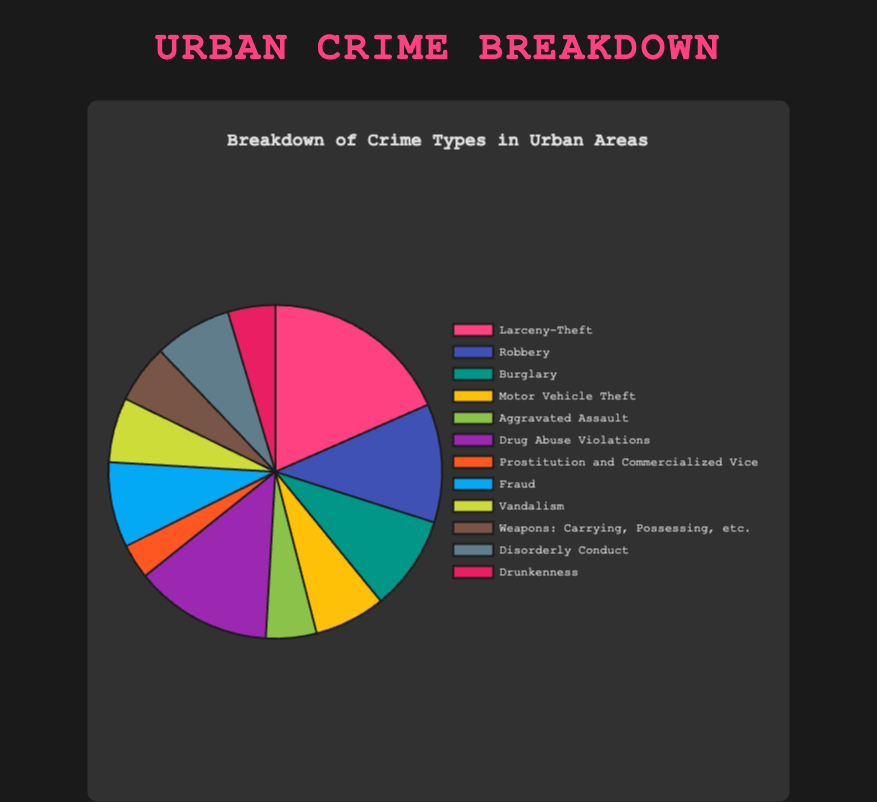What is the most frequent crime type represented in the pie chart? The pie chart shows different crime types with counts. Larceny-Theft has the largest slice, which indicates it is the most frequent crime type with 1200 counts.
Answer: Larceny-Theft Which crime type has a count closest to the average crime count? First, sum all the counts: 1200 + 750 + 600 + 450 + 320 + 870 + 220 + 540 + 410 + 370 + 490 + 300 = 6520. Then, divide by the number of crime types (12). 6520 / 12 = 543.33. Fraud, with a count of 540, is closest to this average.
Answer: Fraud What is the total count for non-violent crimes in the chart? Non-violent crimes here include Larceny-Theft, Burglary, Motor Vehicle Theft, Drug Abuse Violations, Prostitution and Commercialized Vice, Fraud, and Vandalism. Add these counts: 1200 + 600 + 450 + 870 + 220 + 540 + 410 = 4290.
Answer: 4290 Which crime has a larger count: Drug Abuse Violations or Robbery? Compare the two counts: Drug Abuse Violations (870) versus Robbery (750). Drug Abuse Violations has a larger count.
Answer: Drug Abuse Violations What is the combined count of crimes related to theft (Larceny-Theft, Burglary, Motor Vehicle Theft)? Add the counts of the three theft-related crimes: 1200 (Larceny-Theft) + 600 (Burglary) + 450 (Motor Vehicle Theft) = 2250.
Answer: 2250 How many more instances of Larceny-Theft are there compared to Burglary? Subtract the count of Burglary from Larceny-Theft: 1200 - 600 = 600.
Answer: 600 Which crime type is represented by a blue color slice in the pie chart? Referring to the visual attributes, Robbery is represented by the blue color slice.
Answer: Robbery How does the count for Disorderly Conduct compare to that for Vandalism? Compare the two counts: Disorderly Conduct (490) versus Vandalism (410). Disorderly Conduct has more counts.
Answer: Disorderly Conduct What proportion of the total does Aggravated Assault represent? First, find the total counts: 6520. Then, calculate the proportion: (320 / 6520) * 100 ≈ 4.91%.
Answer: 4.91% If you combine the counts of Prostitution and Commercialized Vice and Weapons: Carrying, Possessing, etc., do they surpass any other crime type? Combine the counts: 220 (Prostitution and Commercialized Vice) + 370 (Weapons: Carrying, Possessing, etc.) = 590. This number surpasses the counts of Burglary (600).
Answer: No 